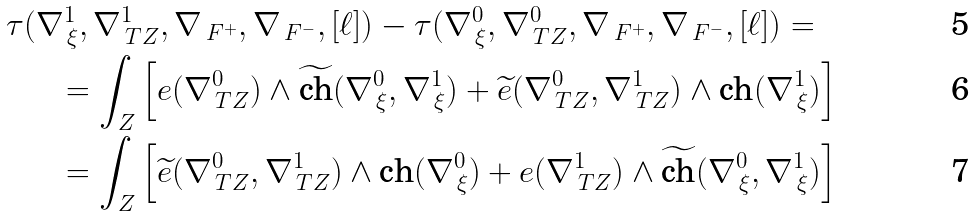Convert formula to latex. <formula><loc_0><loc_0><loc_500><loc_500>\tau & ( \nabla _ { \, \xi } ^ { 1 } , \nabla ^ { 1 } _ { \, T Z } , \nabla _ { \, F ^ { + } } , \nabla _ { \, F ^ { - } } , [ \ell ] ) - \tau ( \nabla ^ { 0 } _ { \, \xi } , \nabla ^ { 0 } _ { \, T Z } , \nabla _ { \, F ^ { + } } , \nabla _ { \, F ^ { - } } , [ \ell ] ) = \\ & \quad = \int _ { Z } \left [ e ( \nabla _ { \, T Z } ^ { 0 } ) \wedge \widetilde { \text {ch} } ( \nabla ^ { 0 } _ { \, \xi } , \nabla ^ { 1 } _ { \, \xi } ) + \widetilde { e } ( \nabla _ { \, T Z } ^ { 0 } , \nabla ^ { 1 } _ { \, T Z } ) \wedge { \text {ch} } ( \nabla ^ { 1 } _ { \, \xi } ) \right ] \\ & \quad = \int _ { Z } \left [ \widetilde { e } ( \nabla _ { \, T Z } ^ { 0 } , \nabla ^ { 1 } _ { \, T Z } ) \wedge { \text {ch} } ( \nabla ^ { 0 } _ { \, \xi } ) + e ( \nabla _ { \, T Z } ^ { 1 } ) \wedge \widetilde { \text {ch} } ( \nabla ^ { 0 } _ { \, \xi } , \nabla ^ { 1 } _ { \, \xi } ) \right ]</formula> 